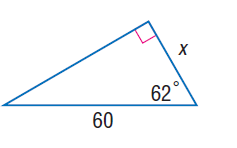Answer the mathemtical geometry problem and directly provide the correct option letter.
Question: Find x.
Choices: A: 22.1 B: 23.4 C: 26.3 D: 28.2 D 